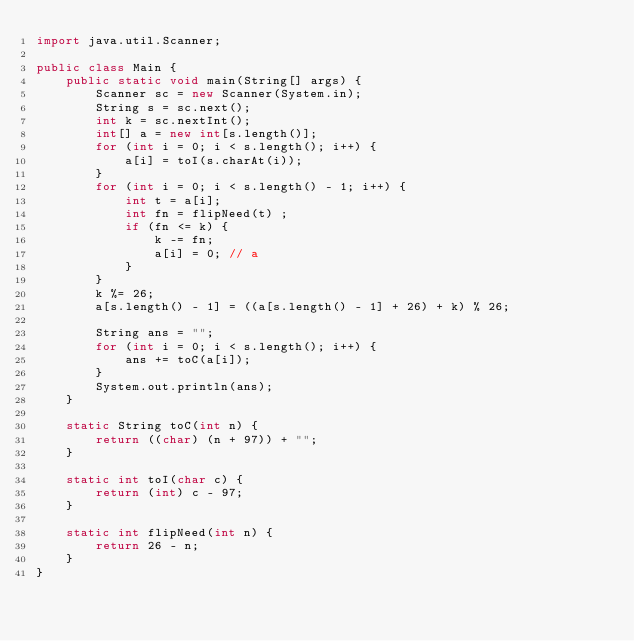<code> <loc_0><loc_0><loc_500><loc_500><_Java_>import java.util.Scanner;

public class Main {
    public static void main(String[] args) {
        Scanner sc = new Scanner(System.in);
        String s = sc.next();
        int k = sc.nextInt();
        int[] a = new int[s.length()];
        for (int i = 0; i < s.length(); i++) {
            a[i] = toI(s.charAt(i));
        }
        for (int i = 0; i < s.length() - 1; i++) {
            int t = a[i];
            int fn = flipNeed(t) ;
            if (fn <= k) {
                k -= fn;
                a[i] = 0; // a
            }
        }
        k %= 26;
        a[s.length() - 1] = ((a[s.length() - 1] + 26) + k) % 26;

        String ans = "";
        for (int i = 0; i < s.length(); i++) {
            ans += toC(a[i]);
        }
        System.out.println(ans);
    }

    static String toC(int n) {
        return ((char) (n + 97)) + "";
    }

    static int toI(char c) {
        return (int) c - 97;
    }

    static int flipNeed(int n) {
        return 26 - n;
    }
}
</code> 